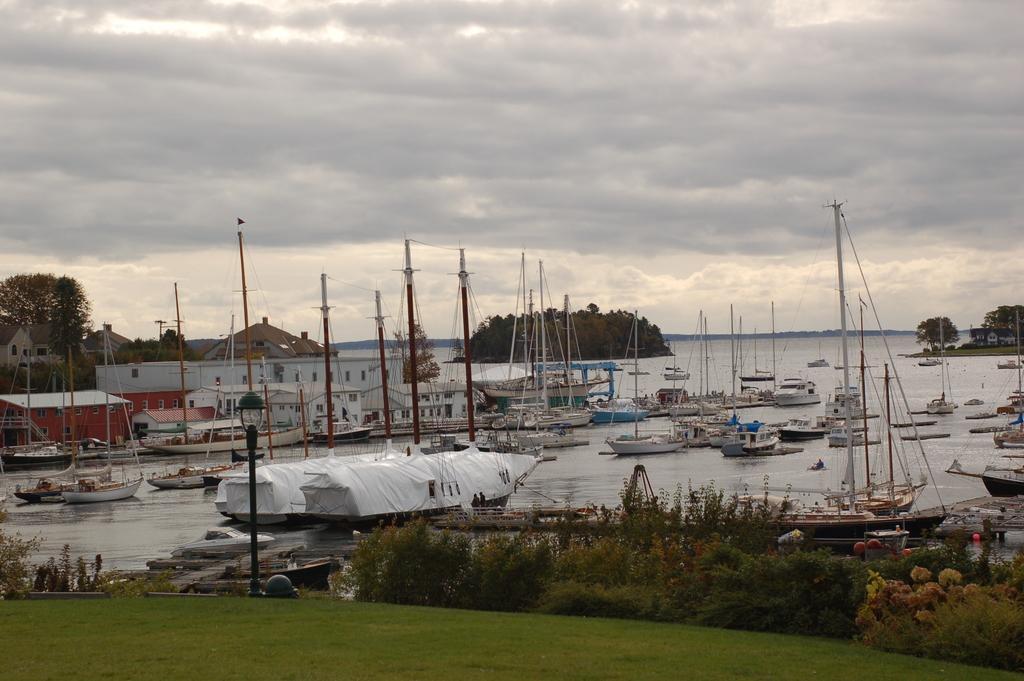How would you summarize this image in a sentence or two? In this picture in the front there's grass on the ground. In the center there are plants and there is a pole. In the background there are boats on the water and there are buildings and there is an ocean and the sky is cloudy. 